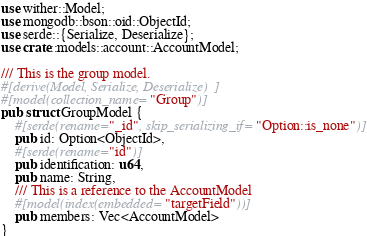Convert code to text. <code><loc_0><loc_0><loc_500><loc_500><_Rust_>use wither::Model;
use mongodb::bson::oid::ObjectId;
use serde::{Serialize, Deserialize};
use crate::models::account::AccountModel;

/// This is the group model.
#[derive(Model, Serialize, Deserialize)]
#[model(collection_name="Group")]
pub struct GroupModel {
    #[serde(rename="_id", skip_serializing_if="Option::is_none")]
    pub id: Option<ObjectId>,
    #[serde(rename="id")]
    pub identification: u64,
    pub name: String,
    /// This is a reference to the AccountModel
    #[model(index(embedded="targetField"))]
    pub members: Vec<AccountModel>
}
</code> 